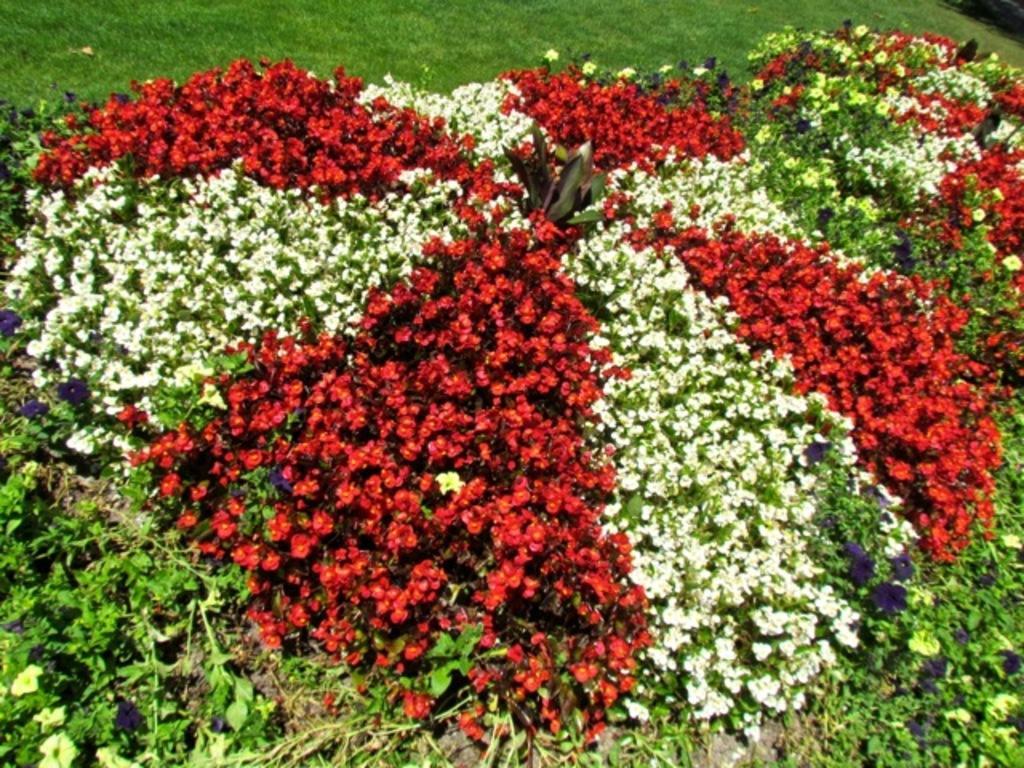Please provide a concise description of this image. In this picture we can see few flowers and plants, in the background we can see grass. 